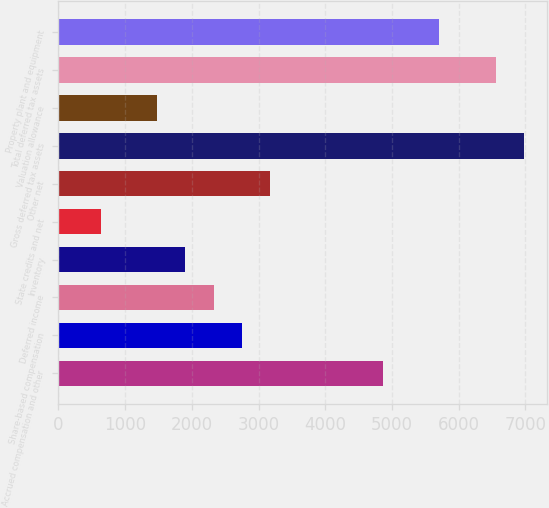Convert chart to OTSL. <chart><loc_0><loc_0><loc_500><loc_500><bar_chart><fcel>Accrued compensation and other<fcel>Share-based compensation<fcel>Deferred income<fcel>Inventory<fcel>State credits and net<fcel>Other net<fcel>Gross deferred tax assets<fcel>Valuation allowance<fcel>Total deferred tax assets<fcel>Property plant and equipment<nl><fcel>4863.8<fcel>2749.8<fcel>2327<fcel>1904.2<fcel>635.8<fcel>3172.6<fcel>6977.8<fcel>1481.4<fcel>6555<fcel>5709.4<nl></chart> 